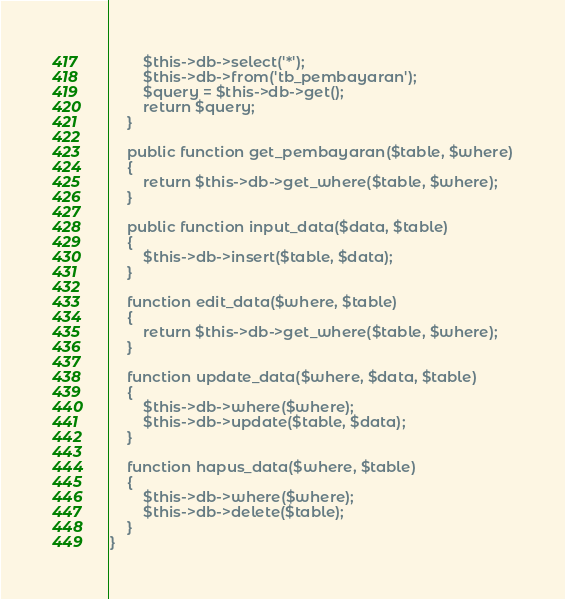<code> <loc_0><loc_0><loc_500><loc_500><_PHP_>        $this->db->select('*');
        $this->db->from('tb_pembayaran');
        $query = $this->db->get();
        return $query;
    }

    public function get_pembayaran($table, $where)
    {
        return $this->db->get_where($table, $where);
    }

    public function input_data($data, $table)
    {
        $this->db->insert($table, $data);
    }

    function edit_data($where, $table)
    {
        return $this->db->get_where($table, $where);
    }

    function update_data($where, $data, $table)
    {
        $this->db->where($where);
        $this->db->update($table, $data);
    }

    function hapus_data($where, $table)
    {
        $this->db->where($where);
        $this->db->delete($table);
    }
}
</code> 